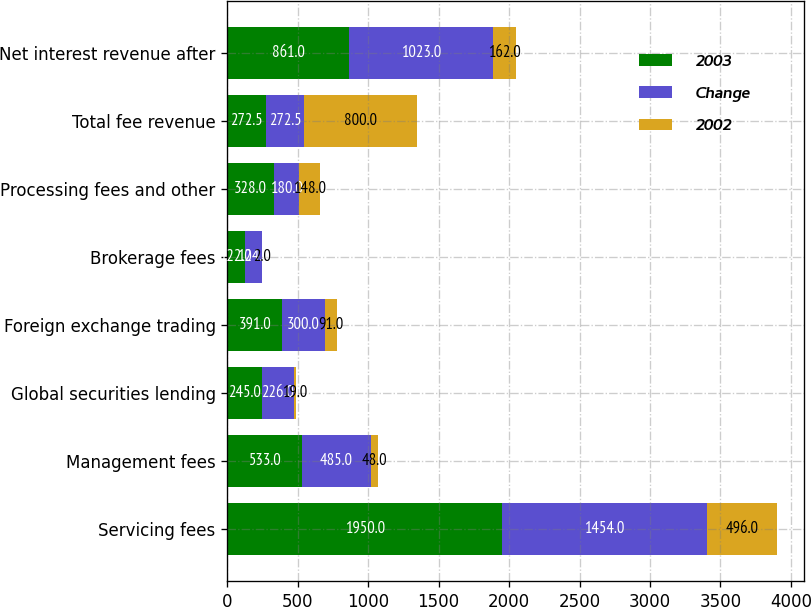Convert chart to OTSL. <chart><loc_0><loc_0><loc_500><loc_500><stacked_bar_chart><ecel><fcel>Servicing fees<fcel>Management fees<fcel>Global securities lending<fcel>Foreign exchange trading<fcel>Brokerage fees<fcel>Processing fees and other<fcel>Total fee revenue<fcel>Net interest revenue after<nl><fcel>2003<fcel>1950<fcel>533<fcel>245<fcel>391<fcel>122<fcel>328<fcel>272.5<fcel>861<nl><fcel>Change<fcel>1454<fcel>485<fcel>226<fcel>300<fcel>124<fcel>180<fcel>272.5<fcel>1023<nl><fcel>2002<fcel>496<fcel>48<fcel>19<fcel>91<fcel>2<fcel>148<fcel>800<fcel>162<nl></chart> 